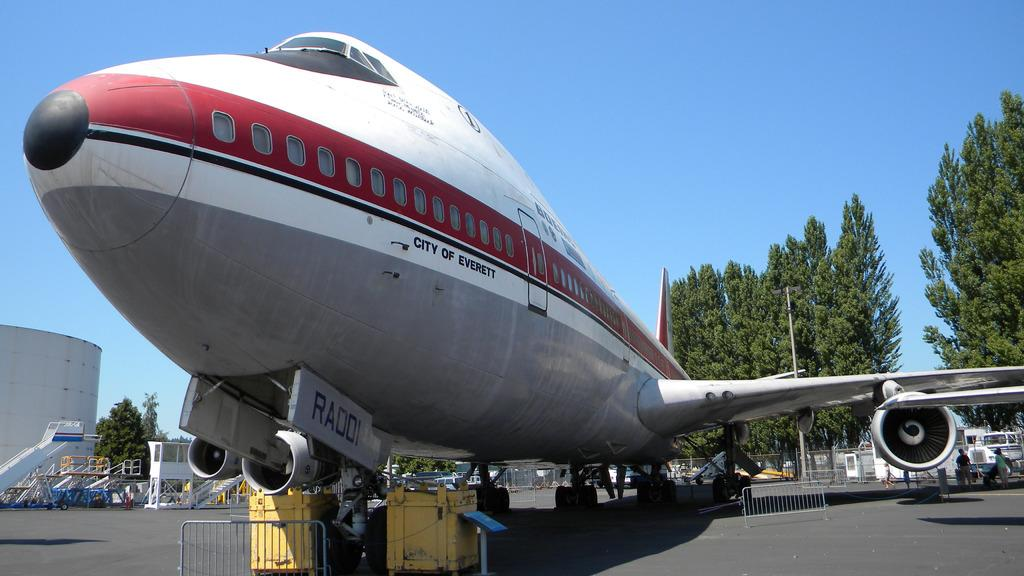<image>
Describe the image concisely. A plane bears the name "city of Everett" on the side of it. 